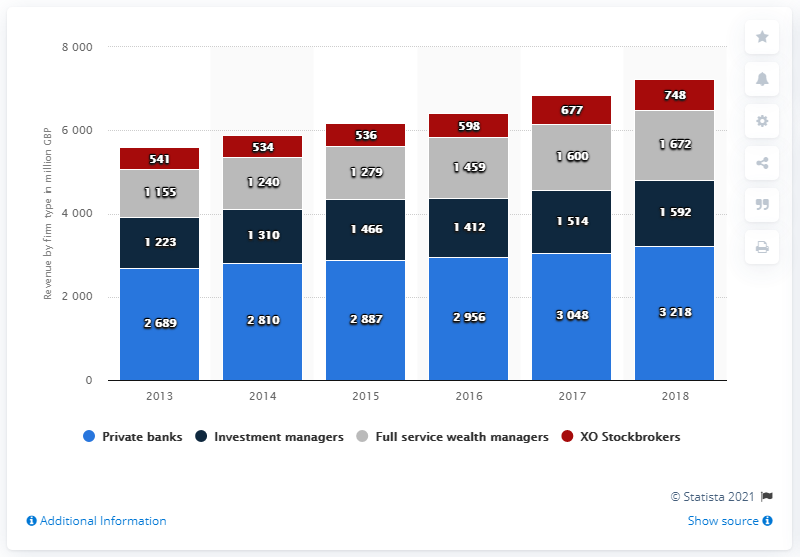Draw attention to some important aspects in this diagram. The highest value in the blue bar is 3218. The average value of investment managers in 2017 and 2018 was 1553. In 2018, the private banking subsector generated approximately $3218 million in revenue. 